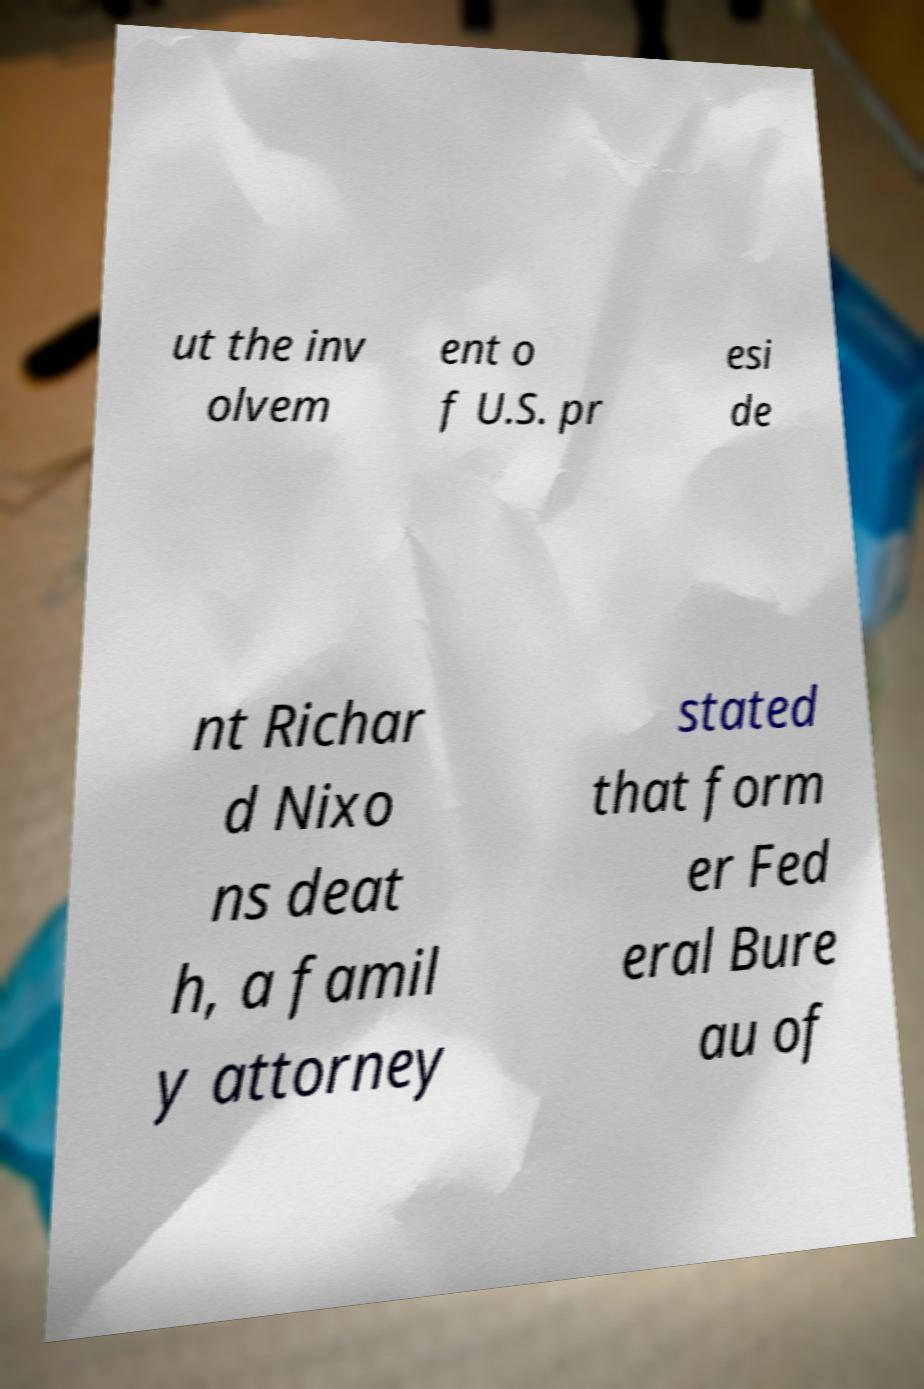For documentation purposes, I need the text within this image transcribed. Could you provide that? ut the inv olvem ent o f U.S. pr esi de nt Richar d Nixo ns deat h, a famil y attorney stated that form er Fed eral Bure au of 